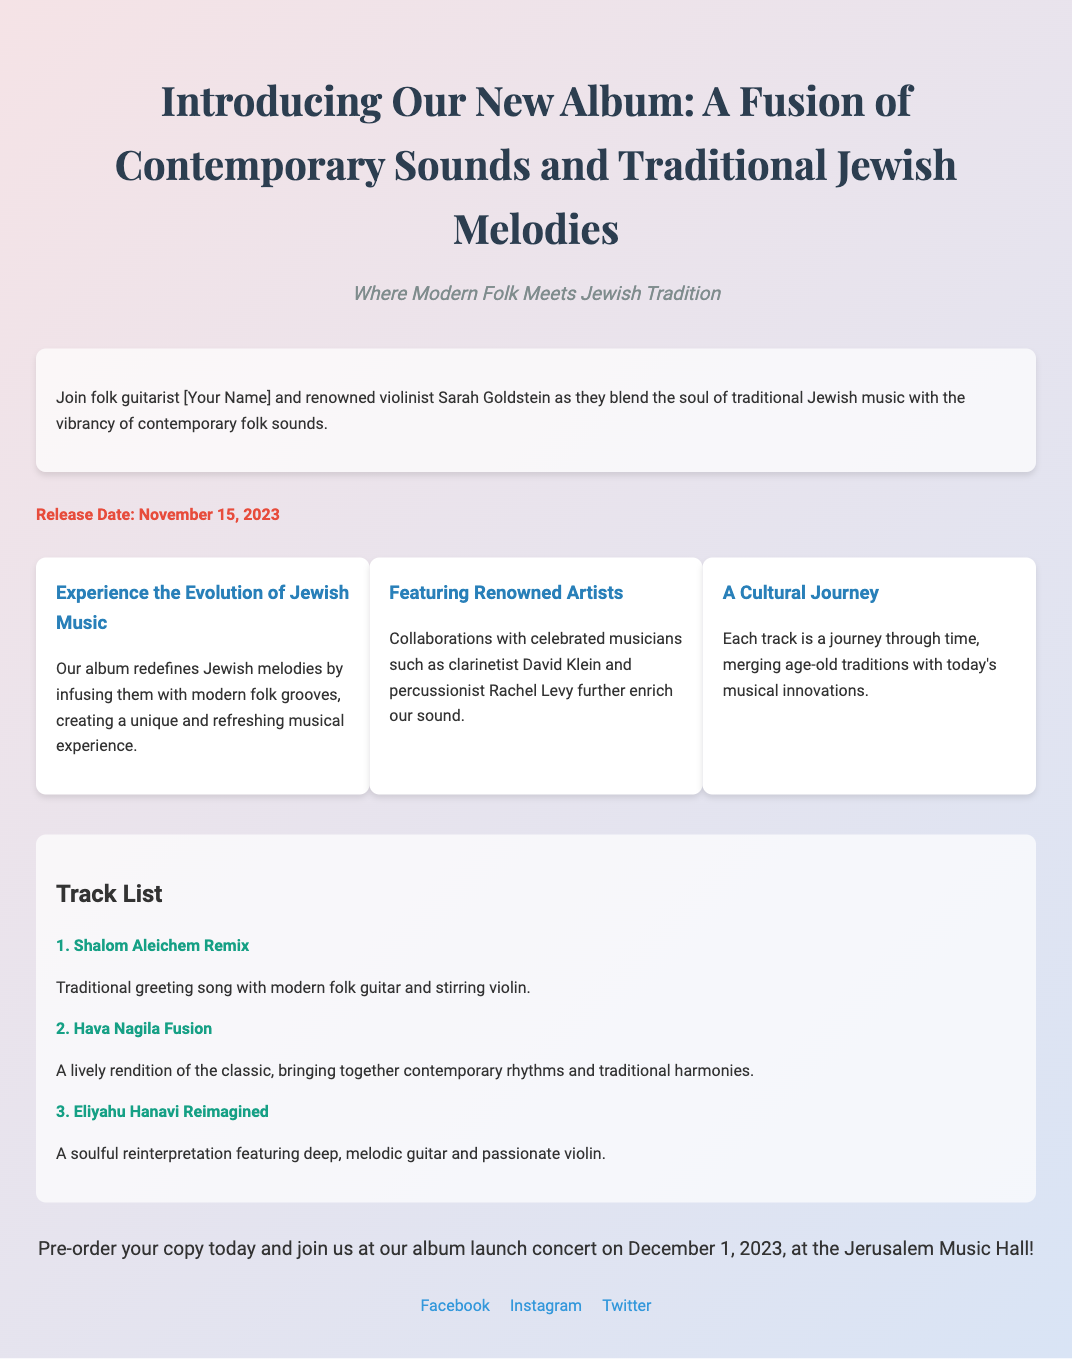What is the album title? The album title is mentioned prominently at the top of the document.
Answer: A Fusion of Contemporary Sounds and Traditional Jewish Melodies Who are the artists featured in the album? The main artists are listed in the persona description section of the document.
Answer: [Your Name] and Sarah Goldstein When is the release date of the album? The release date is highlighted in the document.
Answer: November 15, 2023 What track features a reimagined version of "Eliyahu Hanavi"? The track list specifies each song title.
Answer: Eliyahu Hanavi Reimagined What is the location of the album launch concert? The location is stated in the call-to-action section.
Answer: Jerusalem Music Hall What is the purpose of the album according to the highlights? The highlights outline the intentions of the album regarding music evolution.
Answer: Redefines Jewish melodies Which artist collaborates with the main duo? The highlights mention additional artists contributing to the album.
Answer: David Klein and Rachel Levy What genre is primarily fused with traditional Jewish music? The document describes how the music is characterized.
Answer: Contemporary folk What is the date of the album launch concert? The concert date for the launch is specified in the call-to-action section.
Answer: December 1, 2023 